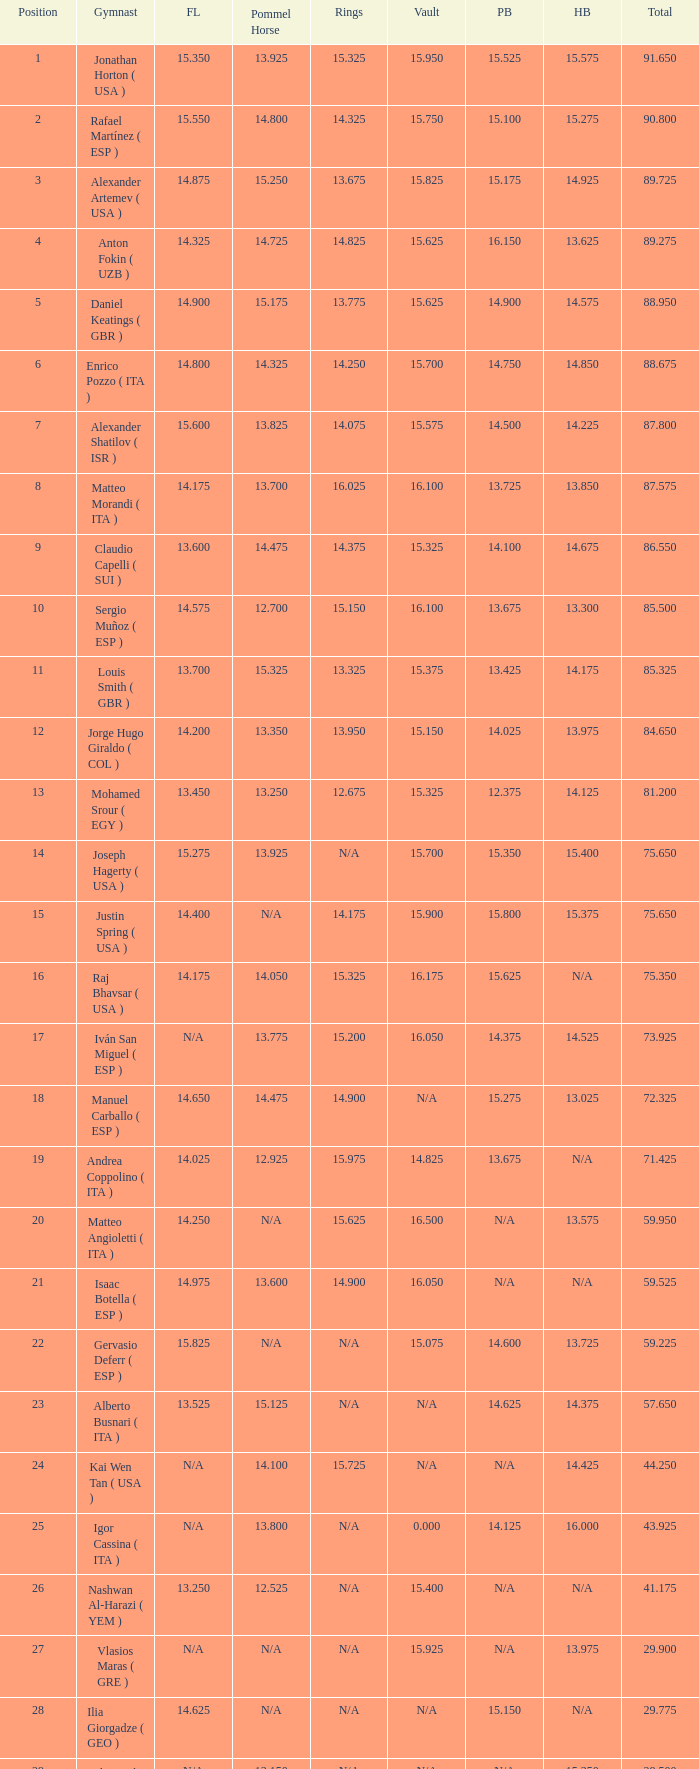If the horizontal bar is n/a and the floor is 14.175, what is the number for the parallel bars? 15.625. 